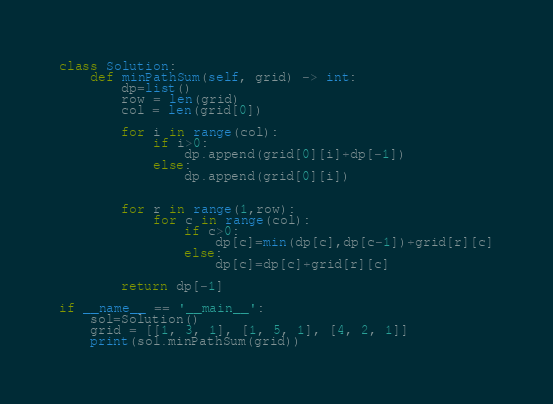<code> <loc_0><loc_0><loc_500><loc_500><_Python_>class Solution:
    def minPathSum(self, grid) -> int:
        dp=list()
        row = len(grid)
        col = len(grid[0])

        for i in range(col):
            if i>0:
                dp.append(grid[0][i]+dp[-1])
            else:
                dp.append(grid[0][i])


        for r in range(1,row):
            for c in range(col):
                if c>0:
                    dp[c]=min(dp[c],dp[c-1])+grid[r][c]
                else:
                    dp[c]=dp[c]+grid[r][c]

        return dp[-1]

if __name__ == '__main__':
    sol=Solution()
    grid = [[1, 3, 1], [1, 5, 1], [4, 2, 1]]
    print(sol.minPathSum(grid))
</code> 